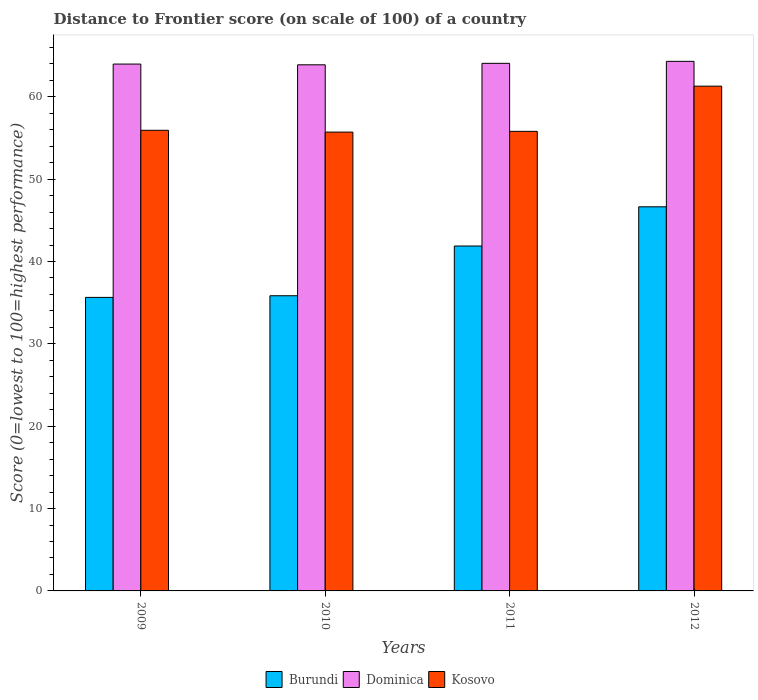How many groups of bars are there?
Keep it short and to the point. 4. How many bars are there on the 3rd tick from the left?
Give a very brief answer. 3. How many bars are there on the 2nd tick from the right?
Provide a succinct answer. 3. What is the label of the 1st group of bars from the left?
Give a very brief answer. 2009. In how many cases, is the number of bars for a given year not equal to the number of legend labels?
Keep it short and to the point. 0. What is the distance to frontier score of in Kosovo in 2011?
Keep it short and to the point. 55.8. Across all years, what is the maximum distance to frontier score of in Kosovo?
Your answer should be very brief. 61.29. Across all years, what is the minimum distance to frontier score of in Dominica?
Your response must be concise. 63.88. In which year was the distance to frontier score of in Kosovo minimum?
Offer a very short reply. 2010. What is the total distance to frontier score of in Dominica in the graph?
Make the answer very short. 256.21. What is the difference between the distance to frontier score of in Dominica in 2011 and that in 2012?
Offer a terse response. -0.24. What is the difference between the distance to frontier score of in Kosovo in 2009 and the distance to frontier score of in Dominica in 2012?
Offer a terse response. -8.37. What is the average distance to frontier score of in Burundi per year?
Your answer should be compact. 40. In the year 2009, what is the difference between the distance to frontier score of in Burundi and distance to frontier score of in Kosovo?
Your answer should be very brief. -20.29. In how many years, is the distance to frontier score of in Kosovo greater than 40?
Offer a terse response. 4. What is the ratio of the distance to frontier score of in Dominica in 2011 to that in 2012?
Your answer should be compact. 1. Is the distance to frontier score of in Burundi in 2009 less than that in 2010?
Your response must be concise. Yes. Is the difference between the distance to frontier score of in Burundi in 2010 and 2011 greater than the difference between the distance to frontier score of in Kosovo in 2010 and 2011?
Your response must be concise. No. What is the difference between the highest and the second highest distance to frontier score of in Kosovo?
Your answer should be compact. 5.36. Is the sum of the distance to frontier score of in Kosovo in 2010 and 2012 greater than the maximum distance to frontier score of in Dominica across all years?
Ensure brevity in your answer.  Yes. What does the 2nd bar from the left in 2009 represents?
Offer a very short reply. Dominica. What does the 1st bar from the right in 2011 represents?
Ensure brevity in your answer.  Kosovo. Is it the case that in every year, the sum of the distance to frontier score of in Dominica and distance to frontier score of in Burundi is greater than the distance to frontier score of in Kosovo?
Your answer should be very brief. Yes. How many bars are there?
Offer a very short reply. 12. Are the values on the major ticks of Y-axis written in scientific E-notation?
Make the answer very short. No. Does the graph contain any zero values?
Offer a very short reply. No. Does the graph contain grids?
Provide a short and direct response. No. How are the legend labels stacked?
Offer a terse response. Horizontal. What is the title of the graph?
Your answer should be very brief. Distance to Frontier score (on scale of 100) of a country. Does "Kiribati" appear as one of the legend labels in the graph?
Your response must be concise. No. What is the label or title of the X-axis?
Provide a succinct answer. Years. What is the label or title of the Y-axis?
Your response must be concise. Score (0=lowest to 100=highest performance). What is the Score (0=lowest to 100=highest performance) in Burundi in 2009?
Keep it short and to the point. 35.64. What is the Score (0=lowest to 100=highest performance) in Dominica in 2009?
Ensure brevity in your answer.  63.97. What is the Score (0=lowest to 100=highest performance) of Kosovo in 2009?
Provide a succinct answer. 55.93. What is the Score (0=lowest to 100=highest performance) in Burundi in 2010?
Provide a succinct answer. 35.84. What is the Score (0=lowest to 100=highest performance) of Dominica in 2010?
Your response must be concise. 63.88. What is the Score (0=lowest to 100=highest performance) in Kosovo in 2010?
Offer a very short reply. 55.71. What is the Score (0=lowest to 100=highest performance) in Burundi in 2011?
Ensure brevity in your answer.  41.88. What is the Score (0=lowest to 100=highest performance) in Dominica in 2011?
Your answer should be very brief. 64.06. What is the Score (0=lowest to 100=highest performance) of Kosovo in 2011?
Offer a very short reply. 55.8. What is the Score (0=lowest to 100=highest performance) in Burundi in 2012?
Keep it short and to the point. 46.64. What is the Score (0=lowest to 100=highest performance) in Dominica in 2012?
Ensure brevity in your answer.  64.3. What is the Score (0=lowest to 100=highest performance) of Kosovo in 2012?
Give a very brief answer. 61.29. Across all years, what is the maximum Score (0=lowest to 100=highest performance) in Burundi?
Your answer should be compact. 46.64. Across all years, what is the maximum Score (0=lowest to 100=highest performance) in Dominica?
Give a very brief answer. 64.3. Across all years, what is the maximum Score (0=lowest to 100=highest performance) in Kosovo?
Keep it short and to the point. 61.29. Across all years, what is the minimum Score (0=lowest to 100=highest performance) in Burundi?
Offer a terse response. 35.64. Across all years, what is the minimum Score (0=lowest to 100=highest performance) in Dominica?
Offer a terse response. 63.88. Across all years, what is the minimum Score (0=lowest to 100=highest performance) in Kosovo?
Your response must be concise. 55.71. What is the total Score (0=lowest to 100=highest performance) in Burundi in the graph?
Your answer should be compact. 160. What is the total Score (0=lowest to 100=highest performance) in Dominica in the graph?
Keep it short and to the point. 256.21. What is the total Score (0=lowest to 100=highest performance) of Kosovo in the graph?
Provide a succinct answer. 228.73. What is the difference between the Score (0=lowest to 100=highest performance) in Burundi in 2009 and that in 2010?
Offer a terse response. -0.2. What is the difference between the Score (0=lowest to 100=highest performance) of Dominica in 2009 and that in 2010?
Make the answer very short. 0.09. What is the difference between the Score (0=lowest to 100=highest performance) in Kosovo in 2009 and that in 2010?
Make the answer very short. 0.22. What is the difference between the Score (0=lowest to 100=highest performance) of Burundi in 2009 and that in 2011?
Make the answer very short. -6.24. What is the difference between the Score (0=lowest to 100=highest performance) in Dominica in 2009 and that in 2011?
Your answer should be compact. -0.09. What is the difference between the Score (0=lowest to 100=highest performance) of Kosovo in 2009 and that in 2011?
Ensure brevity in your answer.  0.13. What is the difference between the Score (0=lowest to 100=highest performance) of Burundi in 2009 and that in 2012?
Provide a short and direct response. -11. What is the difference between the Score (0=lowest to 100=highest performance) in Dominica in 2009 and that in 2012?
Give a very brief answer. -0.33. What is the difference between the Score (0=lowest to 100=highest performance) of Kosovo in 2009 and that in 2012?
Provide a short and direct response. -5.36. What is the difference between the Score (0=lowest to 100=highest performance) in Burundi in 2010 and that in 2011?
Provide a short and direct response. -6.04. What is the difference between the Score (0=lowest to 100=highest performance) of Dominica in 2010 and that in 2011?
Offer a terse response. -0.18. What is the difference between the Score (0=lowest to 100=highest performance) of Kosovo in 2010 and that in 2011?
Your answer should be very brief. -0.09. What is the difference between the Score (0=lowest to 100=highest performance) in Dominica in 2010 and that in 2012?
Provide a short and direct response. -0.42. What is the difference between the Score (0=lowest to 100=highest performance) in Kosovo in 2010 and that in 2012?
Ensure brevity in your answer.  -5.58. What is the difference between the Score (0=lowest to 100=highest performance) of Burundi in 2011 and that in 2012?
Your answer should be compact. -4.76. What is the difference between the Score (0=lowest to 100=highest performance) in Dominica in 2011 and that in 2012?
Keep it short and to the point. -0.24. What is the difference between the Score (0=lowest to 100=highest performance) of Kosovo in 2011 and that in 2012?
Give a very brief answer. -5.49. What is the difference between the Score (0=lowest to 100=highest performance) of Burundi in 2009 and the Score (0=lowest to 100=highest performance) of Dominica in 2010?
Your answer should be compact. -28.24. What is the difference between the Score (0=lowest to 100=highest performance) of Burundi in 2009 and the Score (0=lowest to 100=highest performance) of Kosovo in 2010?
Offer a very short reply. -20.07. What is the difference between the Score (0=lowest to 100=highest performance) in Dominica in 2009 and the Score (0=lowest to 100=highest performance) in Kosovo in 2010?
Provide a succinct answer. 8.26. What is the difference between the Score (0=lowest to 100=highest performance) of Burundi in 2009 and the Score (0=lowest to 100=highest performance) of Dominica in 2011?
Ensure brevity in your answer.  -28.42. What is the difference between the Score (0=lowest to 100=highest performance) in Burundi in 2009 and the Score (0=lowest to 100=highest performance) in Kosovo in 2011?
Offer a very short reply. -20.16. What is the difference between the Score (0=lowest to 100=highest performance) of Dominica in 2009 and the Score (0=lowest to 100=highest performance) of Kosovo in 2011?
Make the answer very short. 8.17. What is the difference between the Score (0=lowest to 100=highest performance) of Burundi in 2009 and the Score (0=lowest to 100=highest performance) of Dominica in 2012?
Offer a terse response. -28.66. What is the difference between the Score (0=lowest to 100=highest performance) in Burundi in 2009 and the Score (0=lowest to 100=highest performance) in Kosovo in 2012?
Your response must be concise. -25.65. What is the difference between the Score (0=lowest to 100=highest performance) in Dominica in 2009 and the Score (0=lowest to 100=highest performance) in Kosovo in 2012?
Offer a very short reply. 2.68. What is the difference between the Score (0=lowest to 100=highest performance) of Burundi in 2010 and the Score (0=lowest to 100=highest performance) of Dominica in 2011?
Your response must be concise. -28.22. What is the difference between the Score (0=lowest to 100=highest performance) in Burundi in 2010 and the Score (0=lowest to 100=highest performance) in Kosovo in 2011?
Your answer should be compact. -19.96. What is the difference between the Score (0=lowest to 100=highest performance) of Dominica in 2010 and the Score (0=lowest to 100=highest performance) of Kosovo in 2011?
Your answer should be very brief. 8.08. What is the difference between the Score (0=lowest to 100=highest performance) in Burundi in 2010 and the Score (0=lowest to 100=highest performance) in Dominica in 2012?
Ensure brevity in your answer.  -28.46. What is the difference between the Score (0=lowest to 100=highest performance) in Burundi in 2010 and the Score (0=lowest to 100=highest performance) in Kosovo in 2012?
Keep it short and to the point. -25.45. What is the difference between the Score (0=lowest to 100=highest performance) of Dominica in 2010 and the Score (0=lowest to 100=highest performance) of Kosovo in 2012?
Offer a very short reply. 2.59. What is the difference between the Score (0=lowest to 100=highest performance) in Burundi in 2011 and the Score (0=lowest to 100=highest performance) in Dominica in 2012?
Your answer should be compact. -22.42. What is the difference between the Score (0=lowest to 100=highest performance) of Burundi in 2011 and the Score (0=lowest to 100=highest performance) of Kosovo in 2012?
Keep it short and to the point. -19.41. What is the difference between the Score (0=lowest to 100=highest performance) in Dominica in 2011 and the Score (0=lowest to 100=highest performance) in Kosovo in 2012?
Keep it short and to the point. 2.77. What is the average Score (0=lowest to 100=highest performance) of Dominica per year?
Give a very brief answer. 64.05. What is the average Score (0=lowest to 100=highest performance) of Kosovo per year?
Provide a short and direct response. 57.18. In the year 2009, what is the difference between the Score (0=lowest to 100=highest performance) of Burundi and Score (0=lowest to 100=highest performance) of Dominica?
Keep it short and to the point. -28.33. In the year 2009, what is the difference between the Score (0=lowest to 100=highest performance) of Burundi and Score (0=lowest to 100=highest performance) of Kosovo?
Make the answer very short. -20.29. In the year 2009, what is the difference between the Score (0=lowest to 100=highest performance) in Dominica and Score (0=lowest to 100=highest performance) in Kosovo?
Offer a terse response. 8.04. In the year 2010, what is the difference between the Score (0=lowest to 100=highest performance) of Burundi and Score (0=lowest to 100=highest performance) of Dominica?
Provide a succinct answer. -28.04. In the year 2010, what is the difference between the Score (0=lowest to 100=highest performance) in Burundi and Score (0=lowest to 100=highest performance) in Kosovo?
Provide a short and direct response. -19.87. In the year 2010, what is the difference between the Score (0=lowest to 100=highest performance) of Dominica and Score (0=lowest to 100=highest performance) of Kosovo?
Give a very brief answer. 8.17. In the year 2011, what is the difference between the Score (0=lowest to 100=highest performance) in Burundi and Score (0=lowest to 100=highest performance) in Dominica?
Provide a succinct answer. -22.18. In the year 2011, what is the difference between the Score (0=lowest to 100=highest performance) of Burundi and Score (0=lowest to 100=highest performance) of Kosovo?
Your response must be concise. -13.92. In the year 2011, what is the difference between the Score (0=lowest to 100=highest performance) of Dominica and Score (0=lowest to 100=highest performance) of Kosovo?
Your response must be concise. 8.26. In the year 2012, what is the difference between the Score (0=lowest to 100=highest performance) in Burundi and Score (0=lowest to 100=highest performance) in Dominica?
Ensure brevity in your answer.  -17.66. In the year 2012, what is the difference between the Score (0=lowest to 100=highest performance) of Burundi and Score (0=lowest to 100=highest performance) of Kosovo?
Ensure brevity in your answer.  -14.65. In the year 2012, what is the difference between the Score (0=lowest to 100=highest performance) of Dominica and Score (0=lowest to 100=highest performance) of Kosovo?
Your response must be concise. 3.01. What is the ratio of the Score (0=lowest to 100=highest performance) of Burundi in 2009 to that in 2011?
Give a very brief answer. 0.85. What is the ratio of the Score (0=lowest to 100=highest performance) in Dominica in 2009 to that in 2011?
Offer a very short reply. 1. What is the ratio of the Score (0=lowest to 100=highest performance) of Burundi in 2009 to that in 2012?
Offer a very short reply. 0.76. What is the ratio of the Score (0=lowest to 100=highest performance) of Dominica in 2009 to that in 2012?
Provide a short and direct response. 0.99. What is the ratio of the Score (0=lowest to 100=highest performance) of Kosovo in 2009 to that in 2012?
Keep it short and to the point. 0.91. What is the ratio of the Score (0=lowest to 100=highest performance) of Burundi in 2010 to that in 2011?
Provide a succinct answer. 0.86. What is the ratio of the Score (0=lowest to 100=highest performance) in Kosovo in 2010 to that in 2011?
Make the answer very short. 1. What is the ratio of the Score (0=lowest to 100=highest performance) in Burundi in 2010 to that in 2012?
Provide a short and direct response. 0.77. What is the ratio of the Score (0=lowest to 100=highest performance) in Dominica in 2010 to that in 2012?
Give a very brief answer. 0.99. What is the ratio of the Score (0=lowest to 100=highest performance) in Kosovo in 2010 to that in 2012?
Offer a very short reply. 0.91. What is the ratio of the Score (0=lowest to 100=highest performance) of Burundi in 2011 to that in 2012?
Your response must be concise. 0.9. What is the ratio of the Score (0=lowest to 100=highest performance) of Dominica in 2011 to that in 2012?
Offer a terse response. 1. What is the ratio of the Score (0=lowest to 100=highest performance) of Kosovo in 2011 to that in 2012?
Provide a short and direct response. 0.91. What is the difference between the highest and the second highest Score (0=lowest to 100=highest performance) in Burundi?
Ensure brevity in your answer.  4.76. What is the difference between the highest and the second highest Score (0=lowest to 100=highest performance) of Dominica?
Offer a terse response. 0.24. What is the difference between the highest and the second highest Score (0=lowest to 100=highest performance) of Kosovo?
Make the answer very short. 5.36. What is the difference between the highest and the lowest Score (0=lowest to 100=highest performance) of Burundi?
Offer a very short reply. 11. What is the difference between the highest and the lowest Score (0=lowest to 100=highest performance) in Dominica?
Make the answer very short. 0.42. What is the difference between the highest and the lowest Score (0=lowest to 100=highest performance) in Kosovo?
Give a very brief answer. 5.58. 